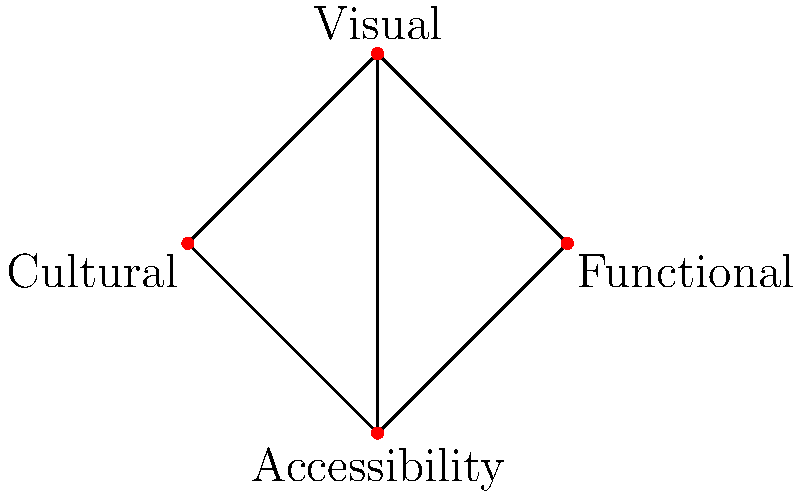In designing an icon set for universal understanding, you've identified four key aspects: Cultural relevance, Visual clarity, Functional representation, and Accessibility. The graph represents these aspects as vertices, with edges indicating relationships between them. How many triangles are formed in this graph, and what might these triangles represent in the context of inclusive icon design? To solve this problem, we need to follow these steps:

1. Identify the triangles in the graph:
   a. Cultural - Visual - Accessibility
   b. Visual - Functional - Accessibility
   c. Cultural - Visual - Functional
   d. Cultural - Functional - Accessibility

2. Count the number of triangles: There are 4 triangles in total.

3. Interpret the meaning of these triangles in the context of inclusive icon design:
   - Each triangle represents a balanced approach considering three out of the four aspects.
   - The presence of multiple triangles suggests that a comprehensive icon design process should consider various combinations of these aspects.
   - For example, the triangle Cultural - Visual - Accessibility emphasizes the need to create visually clear icons that are culturally relevant and accessible to all users.
   - The triangle Visual - Functional - Accessibility highlights the importance of designing icons that are not only visually clear but also functionally representative and accessible.

4. Recognize the significance of the central vertex (Visual clarity):
   - Visual clarity is connected to all other vertices, indicating its crucial role in icon design.
   - This suggests that while balancing other aspects, maintaining visual clarity is paramount for universal understanding.

5. Understand the implications for inclusive design:
   - The interconnectedness of all aspects demonstrates that inclusive icon design requires a holistic approach.
   - Designers must consider cultural nuances, functional representation, accessibility needs, and visual clarity simultaneously to create truly universal icons.
Answer: 4 triangles; balanced combinations of design aspects 